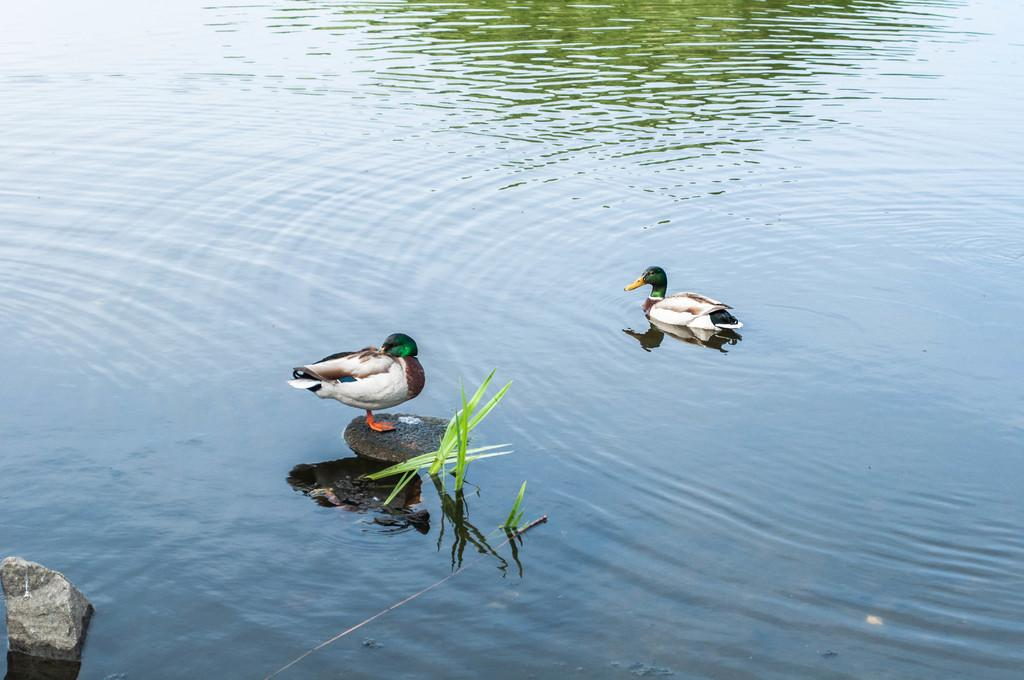What is the primary element present in the image? There is water in the image. What can be seen within the water? There are stones visible in the water. What type of vegetation is present in the image? There is grass visible in the image. What type of animals are present in the image? There are two ducks above the water. What type of fan can be seen in the image? There is no fan present in the image. How many knots are visible in the image? There are no knots present in the image. 